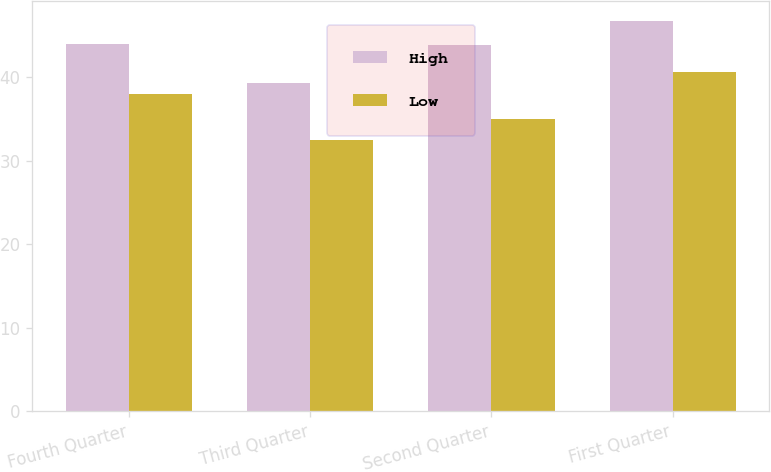<chart> <loc_0><loc_0><loc_500><loc_500><stacked_bar_chart><ecel><fcel>Fourth Quarter<fcel>Third Quarter<fcel>Second Quarter<fcel>First Quarter<nl><fcel>High<fcel>43.97<fcel>39.28<fcel>43.86<fcel>46.77<nl><fcel>Low<fcel>38.06<fcel>32.47<fcel>35<fcel>40.59<nl></chart> 